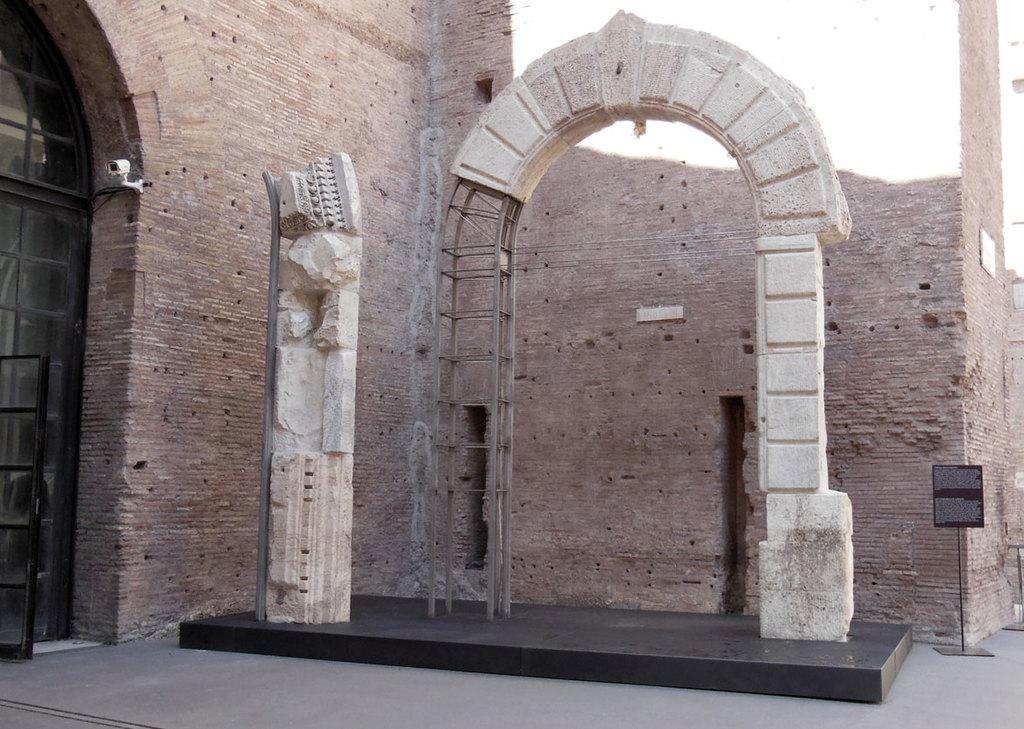What type of structure is visible in the image? There is a building in the image. What is present on the building in the image? There is a wall, poles, a security camera, and a glass door on the wall. Can you describe the floor in the image? The image shows a floor. What is on the stand with text written on it? There is a board on a stand with text written on it. How many rabbits can be seen eating rice in the image? There are no rabbits or rice present in the image. What is the color of the mouth of the person in the image? There is no person visible in the image, so it is not possible to determine the color of their mouth. 